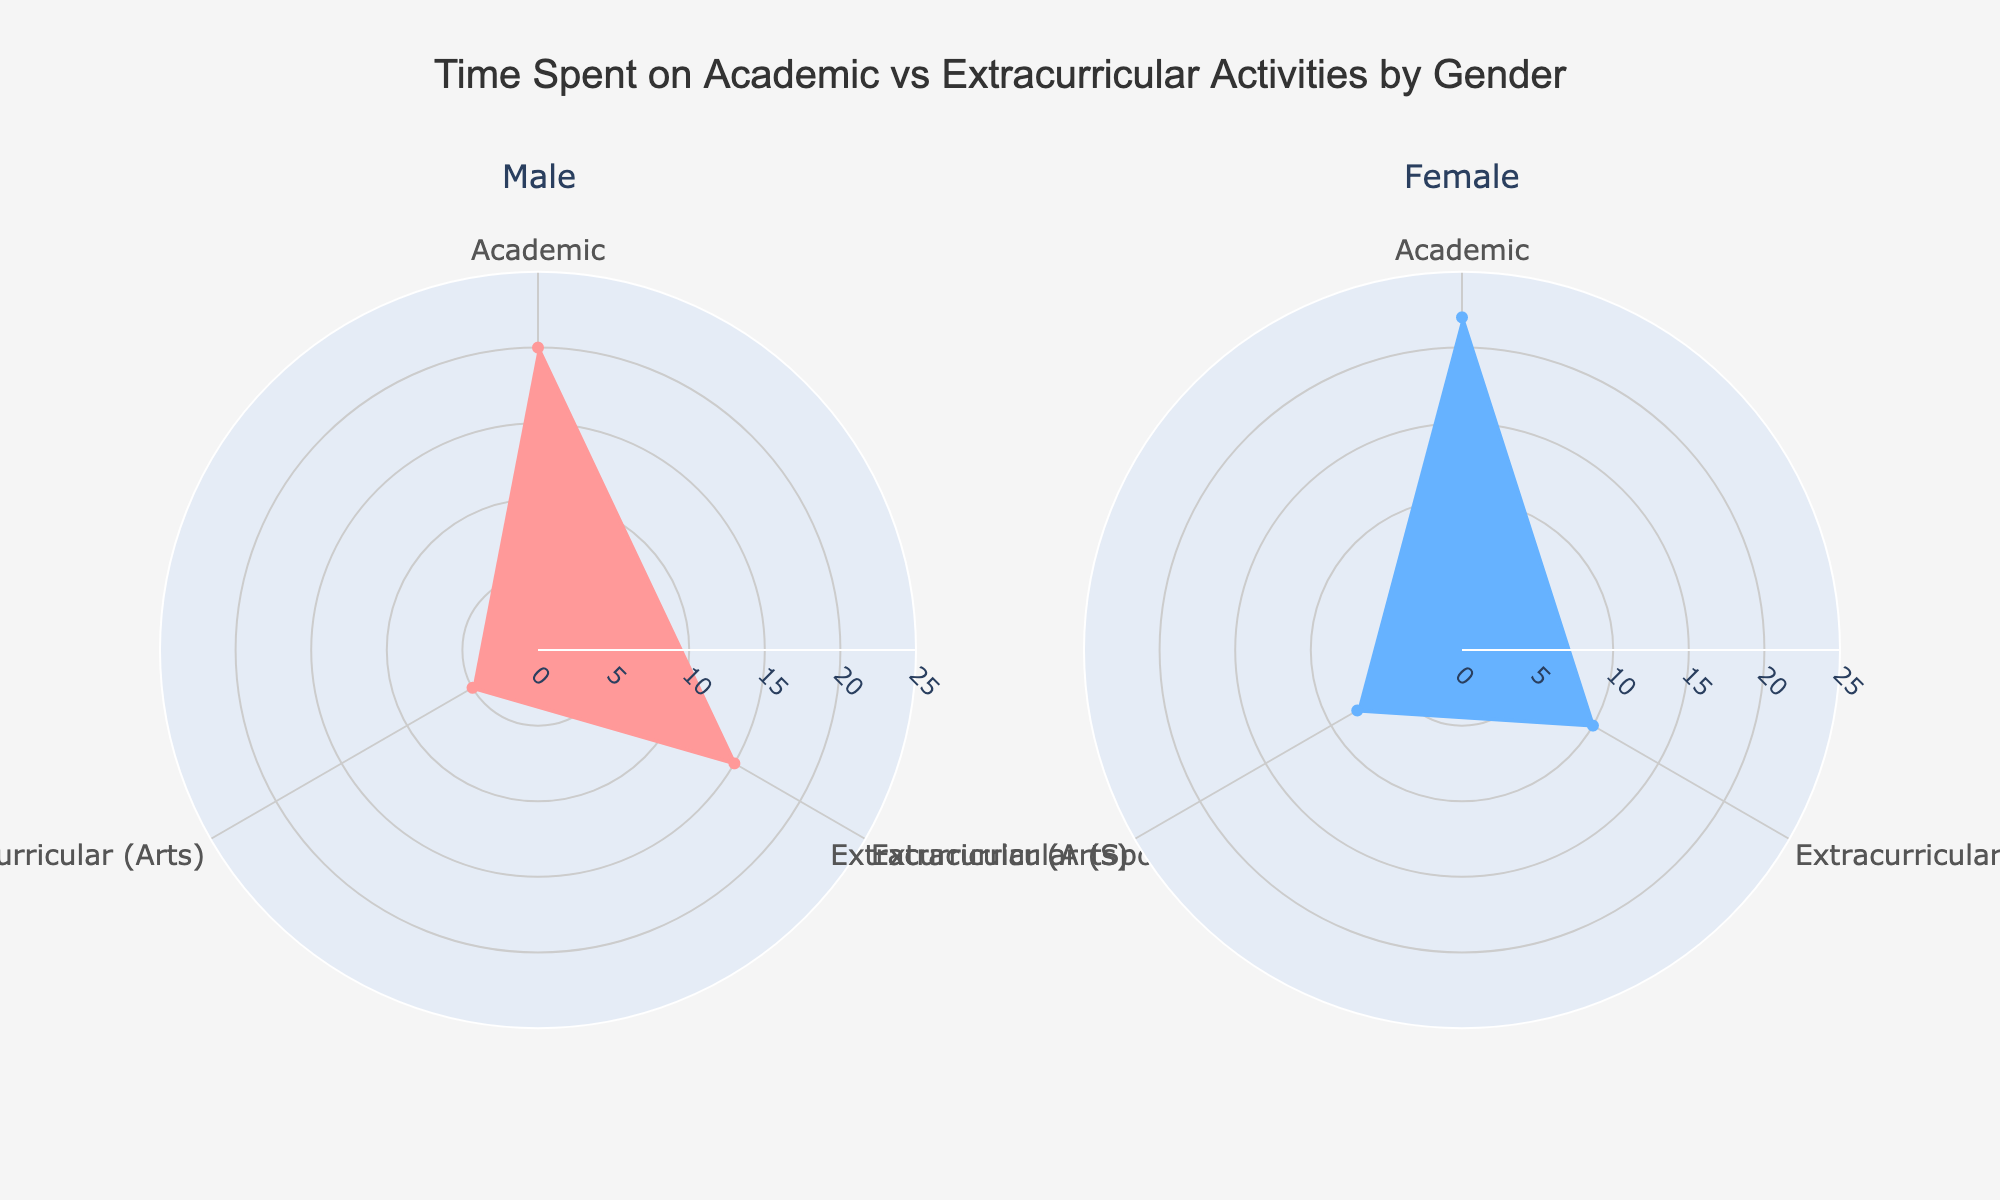What are the main activities analyzed in the chart? The chart investigates three main activities: Academic, Extracurricular (Sports), and Extracurricular (Arts). To determine this, observe the labels on the angular axis of the rose chart.
Answer: Academic, Extracurricular (Sports), Extracurricular (Arts) Which gender spends more time on academic activities? Comparing the lengths of the filled areas for academic activities in both subplots, the one labeled "Female" extends to 22 hours, while the one labeled "Male" extends to 20 hours, indicating that females spend more time on academics.
Answer: Female How much time do males spend on extracurricular (sports) activities compared to females? By comparing the corresponding sections for extracurricular (sports) in both gender subplots, males spend 15 hours, whereas females spend 10 hours. The difference can be observed through the length of the sectors.
Answer: 5 hours more Is there a gender that spends more time on extracurricular (arts) activities? By examining the sections corresponding to extracurricular (arts) activities, males spend 5 hours, and females spend 8 hours. The sectors for females extend further, indicating they spend more time.
Answer: Female What is the total time both genders spend on all activities combined? For males: 20 (Academic) + 15 (Sports) + 5 (Arts) = 40 hours. For females: 22 (Academic) + 10 (Sports) + 8 (Arts) = 40 hours. Summing these gives the total time for each gender.
Answer: 40 hours Which activity shows the largest difference in time spent between genders? Comparing the differences: Academic (2 hours), Extracurricular (Sports) (5 hours), Extracurricular (Arts) (3 hours). The largest difference is in Extracurricular (Sports), with males spending 5 hours more.
Answer: Extracurricular (Sports) What is the average time spent on activities by females? Adding the times females spend on each activity: 22 (Academic) + 10 (Sports) + 8 (Arts) = 40 hours. Dividing by the number of activities (3) gives the average: 40 / 3 ≈ 13.33 hours.
Answer: 13.33 hours Does the time spent on academic activities exceed 50% of the total time for females? Females spend 22 hours on academic activities. To determine if this exceeds 50% of their total time (which is 40 hours), check if 22 > 20 (which represents 50%). Since 22 > 20, it exceeds 50%.
Answer: Yes Considering extracurricular activities, who is more balanced in their time distribution? Males spend 15 hours on sports and 5 hours on arts (ratio of 3:1). In contrast, females spend 10 hours on sports and 8 hours on arts (ratio of ~1.25:1). A more balanced distribution ratio is closer to 1:1. Females have a more balanced approach.
Answer: Female 